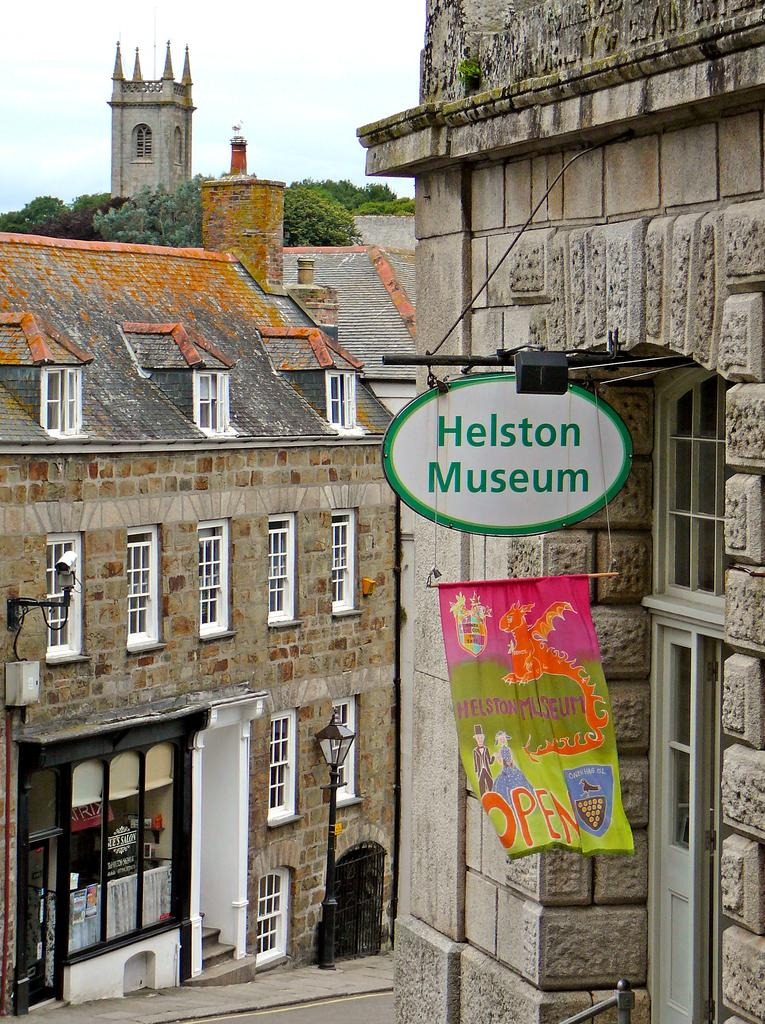What type of structures can be seen in the image? There are buildings, a flag, a board, a light, street lights, a road, trees, and a castle in the image. What is the purpose of the flag in the image? The purpose of the flag in the image is not specified, but it may represent a country, organization, or event. What is the function of the board in the image? The function of the board in the image is not specified, but it could be used for displaying information, advertisements, or announcements. What type of lighting is present in the image? There is a light and street lights in the image, which provide illumination for the area. What type of vegetation is present in the image? There are trees in the image, which provide shade and contribute to the landscape. What type of structure is the castle in the image? The castle in the image is a large, historic building that may have been used for defense or as a residence for royalty. What is visible in the sky in the image? The sky is visible in the image, but the weather or time of day is not specified. What is your opinion on the quiet grandfather in the image? There is no mention of a quiet grandfather in the image, so it is not possible to provide an opinion on this topic. 